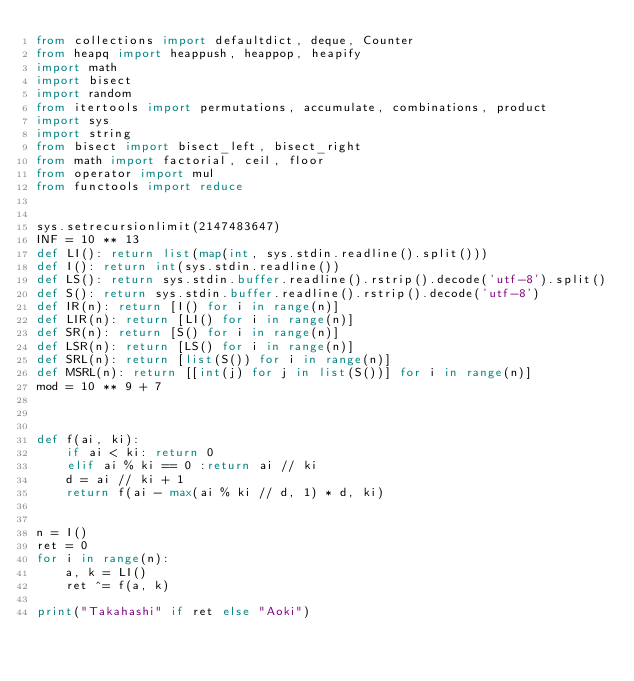Convert code to text. <code><loc_0><loc_0><loc_500><loc_500><_Python_>from collections import defaultdict, deque, Counter
from heapq import heappush, heappop, heapify
import math
import bisect
import random
from itertools import permutations, accumulate, combinations, product
import sys
import string
from bisect import bisect_left, bisect_right
from math import factorial, ceil, floor
from operator import mul
from functools import reduce


sys.setrecursionlimit(2147483647)
INF = 10 ** 13
def LI(): return list(map(int, sys.stdin.readline().split()))
def I(): return int(sys.stdin.readline())
def LS(): return sys.stdin.buffer.readline().rstrip().decode('utf-8').split()
def S(): return sys.stdin.buffer.readline().rstrip().decode('utf-8')
def IR(n): return [I() for i in range(n)]
def LIR(n): return [LI() for i in range(n)]
def SR(n): return [S() for i in range(n)]
def LSR(n): return [LS() for i in range(n)]
def SRL(n): return [list(S()) for i in range(n)]
def MSRL(n): return [[int(j) for j in list(S())] for i in range(n)]
mod = 10 ** 9 + 7



def f(ai, ki):
    if ai < ki: return 0
    elif ai % ki == 0 :return ai // ki
    d = ai // ki + 1
    return f(ai - max(ai % ki // d, 1) * d, ki)


n = I()
ret = 0
for i in range(n):
    a, k = LI()
    ret ^= f(a, k)

print("Takahashi" if ret else "Aoki")</code> 